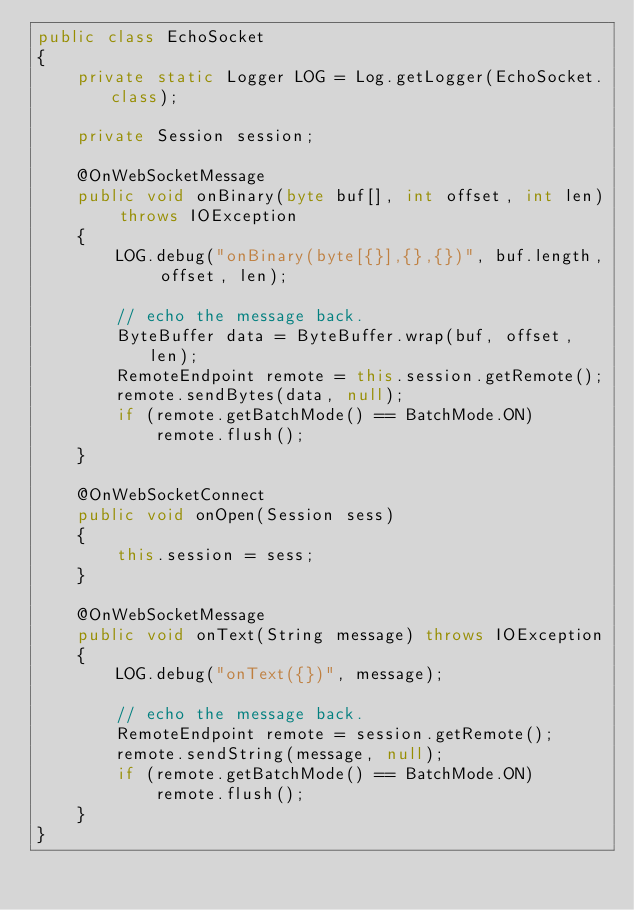<code> <loc_0><loc_0><loc_500><loc_500><_Java_>public class EchoSocket
{
    private static Logger LOG = Log.getLogger(EchoSocket.class);

    private Session session;

    @OnWebSocketMessage
    public void onBinary(byte buf[], int offset, int len) throws IOException
    {
        LOG.debug("onBinary(byte[{}],{},{})", buf.length, offset, len);

        // echo the message back.
        ByteBuffer data = ByteBuffer.wrap(buf, offset, len);
        RemoteEndpoint remote = this.session.getRemote();
        remote.sendBytes(data, null);
        if (remote.getBatchMode() == BatchMode.ON)
            remote.flush();
    }

    @OnWebSocketConnect
    public void onOpen(Session sess)
    {
        this.session = sess;
    }

    @OnWebSocketMessage
    public void onText(String message) throws IOException
    {
        LOG.debug("onText({})", message);

        // echo the message back.
        RemoteEndpoint remote = session.getRemote();
        remote.sendString(message, null);
        if (remote.getBatchMode() == BatchMode.ON)
            remote.flush();
    }
}
</code> 